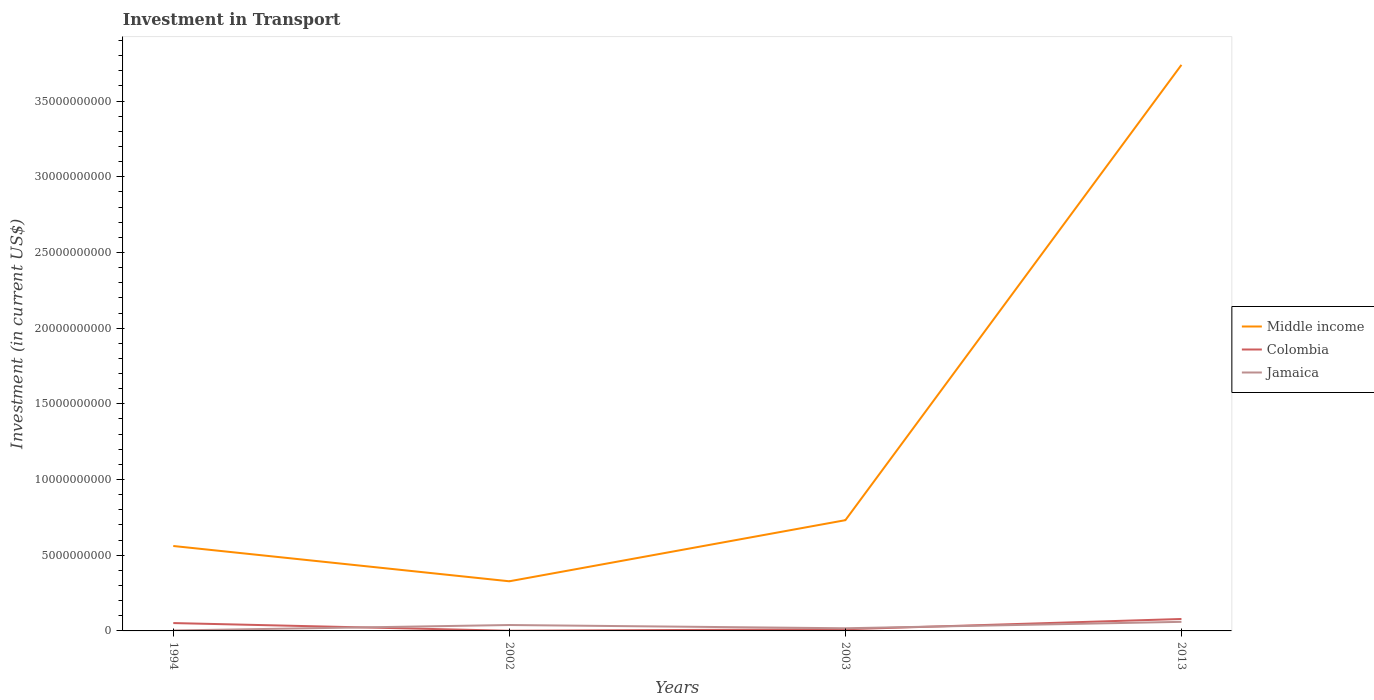How many different coloured lines are there?
Give a very brief answer. 3. Across all years, what is the maximum amount invested in transport in Colombia?
Offer a terse response. 1.08e+07. What is the total amount invested in transport in Colombia in the graph?
Offer a terse response. 4.08e+08. What is the difference between the highest and the second highest amount invested in transport in Colombia?
Keep it short and to the point. 7.78e+08. What is the difference between two consecutive major ticks on the Y-axis?
Keep it short and to the point. 5.00e+09. Are the values on the major ticks of Y-axis written in scientific E-notation?
Make the answer very short. No. Does the graph contain any zero values?
Offer a very short reply. No. Does the graph contain grids?
Your answer should be very brief. No. Where does the legend appear in the graph?
Give a very brief answer. Center right. What is the title of the graph?
Ensure brevity in your answer.  Investment in Transport. What is the label or title of the X-axis?
Your answer should be compact. Years. What is the label or title of the Y-axis?
Give a very brief answer. Investment (in current US$). What is the Investment (in current US$) of Middle income in 1994?
Give a very brief answer. 5.61e+09. What is the Investment (in current US$) in Colombia in 1994?
Make the answer very short. 5.19e+08. What is the Investment (in current US$) in Jamaica in 1994?
Provide a succinct answer. 3.00e+07. What is the Investment (in current US$) of Middle income in 2002?
Ensure brevity in your answer.  3.28e+09. What is the Investment (in current US$) in Colombia in 2002?
Keep it short and to the point. 1.08e+07. What is the Investment (in current US$) in Jamaica in 2002?
Ensure brevity in your answer.  3.90e+08. What is the Investment (in current US$) of Middle income in 2003?
Your answer should be very brief. 7.32e+09. What is the Investment (in current US$) of Colombia in 2003?
Provide a short and direct response. 1.10e+08. What is the Investment (in current US$) of Jamaica in 2003?
Your response must be concise. 1.75e+08. What is the Investment (in current US$) in Middle income in 2013?
Provide a short and direct response. 3.74e+1. What is the Investment (in current US$) in Colombia in 2013?
Provide a short and direct response. 7.89e+08. What is the Investment (in current US$) in Jamaica in 2013?
Your answer should be compact. 6.00e+08. Across all years, what is the maximum Investment (in current US$) of Middle income?
Provide a short and direct response. 3.74e+1. Across all years, what is the maximum Investment (in current US$) of Colombia?
Make the answer very short. 7.89e+08. Across all years, what is the maximum Investment (in current US$) in Jamaica?
Your answer should be compact. 6.00e+08. Across all years, what is the minimum Investment (in current US$) in Middle income?
Offer a terse response. 3.28e+09. Across all years, what is the minimum Investment (in current US$) in Colombia?
Offer a terse response. 1.08e+07. Across all years, what is the minimum Investment (in current US$) in Jamaica?
Your answer should be compact. 3.00e+07. What is the total Investment (in current US$) in Middle income in the graph?
Your answer should be very brief. 5.36e+1. What is the total Investment (in current US$) in Colombia in the graph?
Give a very brief answer. 1.43e+09. What is the total Investment (in current US$) of Jamaica in the graph?
Your response must be concise. 1.20e+09. What is the difference between the Investment (in current US$) in Middle income in 1994 and that in 2002?
Offer a terse response. 2.33e+09. What is the difference between the Investment (in current US$) of Colombia in 1994 and that in 2002?
Make the answer very short. 5.08e+08. What is the difference between the Investment (in current US$) in Jamaica in 1994 and that in 2002?
Offer a very short reply. -3.60e+08. What is the difference between the Investment (in current US$) of Middle income in 1994 and that in 2003?
Give a very brief answer. -1.70e+09. What is the difference between the Investment (in current US$) of Colombia in 1994 and that in 2003?
Your answer should be very brief. 4.08e+08. What is the difference between the Investment (in current US$) of Jamaica in 1994 and that in 2003?
Your answer should be compact. -1.45e+08. What is the difference between the Investment (in current US$) of Middle income in 1994 and that in 2013?
Make the answer very short. -3.18e+1. What is the difference between the Investment (in current US$) of Colombia in 1994 and that in 2013?
Give a very brief answer. -2.70e+08. What is the difference between the Investment (in current US$) in Jamaica in 1994 and that in 2013?
Provide a short and direct response. -5.70e+08. What is the difference between the Investment (in current US$) of Middle income in 2002 and that in 2003?
Ensure brevity in your answer.  -4.04e+09. What is the difference between the Investment (in current US$) in Colombia in 2002 and that in 2003?
Keep it short and to the point. -9.96e+07. What is the difference between the Investment (in current US$) of Jamaica in 2002 and that in 2003?
Keep it short and to the point. 2.15e+08. What is the difference between the Investment (in current US$) in Middle income in 2002 and that in 2013?
Offer a terse response. -3.41e+1. What is the difference between the Investment (in current US$) of Colombia in 2002 and that in 2013?
Your response must be concise. -7.78e+08. What is the difference between the Investment (in current US$) of Jamaica in 2002 and that in 2013?
Keep it short and to the point. -2.10e+08. What is the difference between the Investment (in current US$) in Middle income in 2003 and that in 2013?
Give a very brief answer. -3.01e+1. What is the difference between the Investment (in current US$) in Colombia in 2003 and that in 2013?
Offer a terse response. -6.78e+08. What is the difference between the Investment (in current US$) in Jamaica in 2003 and that in 2013?
Give a very brief answer. -4.25e+08. What is the difference between the Investment (in current US$) of Middle income in 1994 and the Investment (in current US$) of Colombia in 2002?
Provide a succinct answer. 5.60e+09. What is the difference between the Investment (in current US$) in Middle income in 1994 and the Investment (in current US$) in Jamaica in 2002?
Provide a succinct answer. 5.22e+09. What is the difference between the Investment (in current US$) of Colombia in 1994 and the Investment (in current US$) of Jamaica in 2002?
Keep it short and to the point. 1.29e+08. What is the difference between the Investment (in current US$) in Middle income in 1994 and the Investment (in current US$) in Colombia in 2003?
Provide a short and direct response. 5.50e+09. What is the difference between the Investment (in current US$) of Middle income in 1994 and the Investment (in current US$) of Jamaica in 2003?
Keep it short and to the point. 5.44e+09. What is the difference between the Investment (in current US$) in Colombia in 1994 and the Investment (in current US$) in Jamaica in 2003?
Keep it short and to the point. 3.44e+08. What is the difference between the Investment (in current US$) of Middle income in 1994 and the Investment (in current US$) of Colombia in 2013?
Offer a very short reply. 4.82e+09. What is the difference between the Investment (in current US$) in Middle income in 1994 and the Investment (in current US$) in Jamaica in 2013?
Give a very brief answer. 5.01e+09. What is the difference between the Investment (in current US$) of Colombia in 1994 and the Investment (in current US$) of Jamaica in 2013?
Provide a short and direct response. -8.11e+07. What is the difference between the Investment (in current US$) in Middle income in 2002 and the Investment (in current US$) in Colombia in 2003?
Provide a succinct answer. 3.17e+09. What is the difference between the Investment (in current US$) in Middle income in 2002 and the Investment (in current US$) in Jamaica in 2003?
Keep it short and to the point. 3.10e+09. What is the difference between the Investment (in current US$) of Colombia in 2002 and the Investment (in current US$) of Jamaica in 2003?
Keep it short and to the point. -1.64e+08. What is the difference between the Investment (in current US$) in Middle income in 2002 and the Investment (in current US$) in Colombia in 2013?
Keep it short and to the point. 2.49e+09. What is the difference between the Investment (in current US$) of Middle income in 2002 and the Investment (in current US$) of Jamaica in 2013?
Ensure brevity in your answer.  2.68e+09. What is the difference between the Investment (in current US$) in Colombia in 2002 and the Investment (in current US$) in Jamaica in 2013?
Your answer should be very brief. -5.89e+08. What is the difference between the Investment (in current US$) in Middle income in 2003 and the Investment (in current US$) in Colombia in 2013?
Offer a very short reply. 6.53e+09. What is the difference between the Investment (in current US$) of Middle income in 2003 and the Investment (in current US$) of Jamaica in 2013?
Offer a terse response. 6.72e+09. What is the difference between the Investment (in current US$) in Colombia in 2003 and the Investment (in current US$) in Jamaica in 2013?
Provide a short and direct response. -4.90e+08. What is the average Investment (in current US$) in Middle income per year?
Your response must be concise. 1.34e+1. What is the average Investment (in current US$) of Colombia per year?
Offer a very short reply. 3.57e+08. What is the average Investment (in current US$) in Jamaica per year?
Your response must be concise. 2.99e+08. In the year 1994, what is the difference between the Investment (in current US$) of Middle income and Investment (in current US$) of Colombia?
Your answer should be compact. 5.09e+09. In the year 1994, what is the difference between the Investment (in current US$) of Middle income and Investment (in current US$) of Jamaica?
Provide a short and direct response. 5.58e+09. In the year 1994, what is the difference between the Investment (in current US$) of Colombia and Investment (in current US$) of Jamaica?
Ensure brevity in your answer.  4.89e+08. In the year 2002, what is the difference between the Investment (in current US$) in Middle income and Investment (in current US$) in Colombia?
Your response must be concise. 3.27e+09. In the year 2002, what is the difference between the Investment (in current US$) in Middle income and Investment (in current US$) in Jamaica?
Your answer should be compact. 2.89e+09. In the year 2002, what is the difference between the Investment (in current US$) of Colombia and Investment (in current US$) of Jamaica?
Ensure brevity in your answer.  -3.79e+08. In the year 2003, what is the difference between the Investment (in current US$) of Middle income and Investment (in current US$) of Colombia?
Your answer should be very brief. 7.20e+09. In the year 2003, what is the difference between the Investment (in current US$) in Middle income and Investment (in current US$) in Jamaica?
Provide a short and direct response. 7.14e+09. In the year 2003, what is the difference between the Investment (in current US$) of Colombia and Investment (in current US$) of Jamaica?
Give a very brief answer. -6.46e+07. In the year 2013, what is the difference between the Investment (in current US$) of Middle income and Investment (in current US$) of Colombia?
Provide a short and direct response. 3.66e+1. In the year 2013, what is the difference between the Investment (in current US$) of Middle income and Investment (in current US$) of Jamaica?
Provide a short and direct response. 3.68e+1. In the year 2013, what is the difference between the Investment (in current US$) of Colombia and Investment (in current US$) of Jamaica?
Offer a terse response. 1.89e+08. What is the ratio of the Investment (in current US$) in Middle income in 1994 to that in 2002?
Your answer should be compact. 1.71. What is the ratio of the Investment (in current US$) of Colombia in 1994 to that in 2002?
Your answer should be very brief. 48.05. What is the ratio of the Investment (in current US$) of Jamaica in 1994 to that in 2002?
Make the answer very short. 0.08. What is the ratio of the Investment (in current US$) of Middle income in 1994 to that in 2003?
Make the answer very short. 0.77. What is the ratio of the Investment (in current US$) in Colombia in 1994 to that in 2003?
Offer a very short reply. 4.7. What is the ratio of the Investment (in current US$) in Jamaica in 1994 to that in 2003?
Your answer should be very brief. 0.17. What is the ratio of the Investment (in current US$) of Middle income in 1994 to that in 2013?
Keep it short and to the point. 0.15. What is the ratio of the Investment (in current US$) in Colombia in 1994 to that in 2013?
Your answer should be compact. 0.66. What is the ratio of the Investment (in current US$) of Middle income in 2002 to that in 2003?
Offer a very short reply. 0.45. What is the ratio of the Investment (in current US$) in Colombia in 2002 to that in 2003?
Keep it short and to the point. 0.1. What is the ratio of the Investment (in current US$) of Jamaica in 2002 to that in 2003?
Keep it short and to the point. 2.23. What is the ratio of the Investment (in current US$) in Middle income in 2002 to that in 2013?
Your answer should be very brief. 0.09. What is the ratio of the Investment (in current US$) of Colombia in 2002 to that in 2013?
Give a very brief answer. 0.01. What is the ratio of the Investment (in current US$) in Jamaica in 2002 to that in 2013?
Your response must be concise. 0.65. What is the ratio of the Investment (in current US$) of Middle income in 2003 to that in 2013?
Ensure brevity in your answer.  0.2. What is the ratio of the Investment (in current US$) in Colombia in 2003 to that in 2013?
Your answer should be compact. 0.14. What is the ratio of the Investment (in current US$) of Jamaica in 2003 to that in 2013?
Your answer should be very brief. 0.29. What is the difference between the highest and the second highest Investment (in current US$) in Middle income?
Provide a succinct answer. 3.01e+1. What is the difference between the highest and the second highest Investment (in current US$) in Colombia?
Offer a very short reply. 2.70e+08. What is the difference between the highest and the second highest Investment (in current US$) of Jamaica?
Offer a terse response. 2.10e+08. What is the difference between the highest and the lowest Investment (in current US$) of Middle income?
Offer a very short reply. 3.41e+1. What is the difference between the highest and the lowest Investment (in current US$) in Colombia?
Your answer should be very brief. 7.78e+08. What is the difference between the highest and the lowest Investment (in current US$) of Jamaica?
Your answer should be compact. 5.70e+08. 